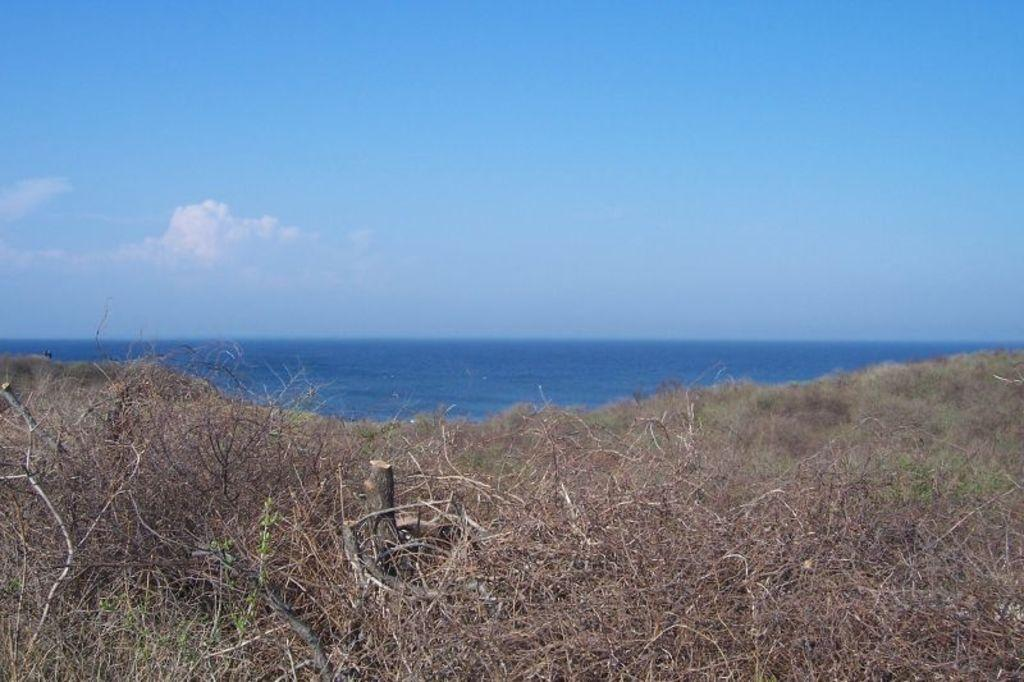What type of vegetation can be seen in the image? There is dried grass in the image. What natural element is also visible in the image? There is water visible in the image. What is the color of the water? The water is blue in color. What can be seen in the background of the image? There is a sky visible in the background of the image. What are the clouds like in the sky? Clouds are present in the sky. Can you see the brain of the frog in the image? There is no frog or brain present in the image. What is the back of the image made of? The image is a flat, two-dimensional representation, so it does not have a back. 